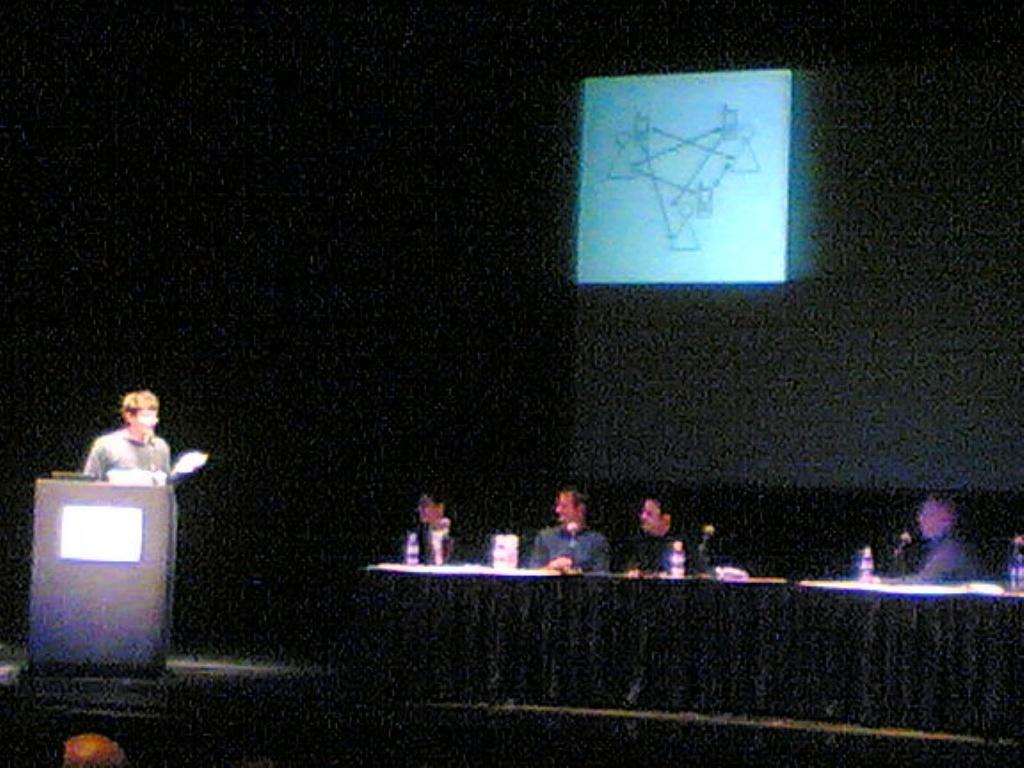Please provide a concise description of this image. In this image we can see few people sitting. In front of them there is a platform with mics, bottles and some other items. Also there is a person standing. Near to him there is a podium with mic. In the back there is a wall with screen. 